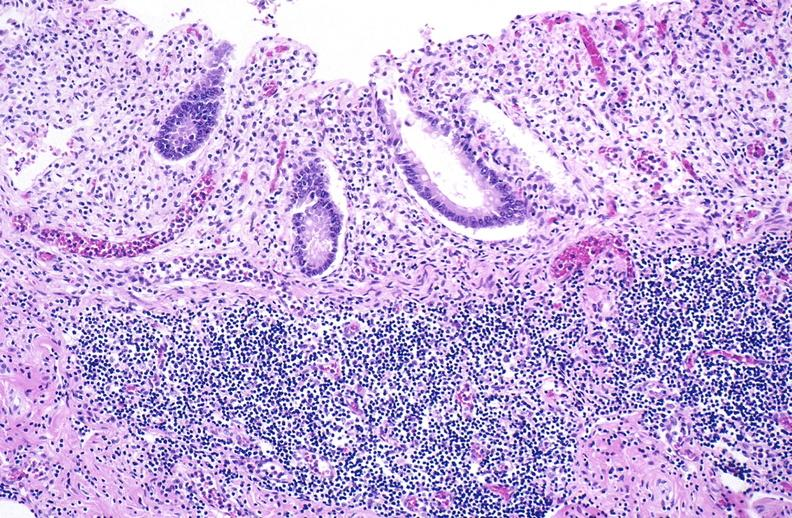what does this image show?
Answer the question using a single word or phrase. Normal appendix 